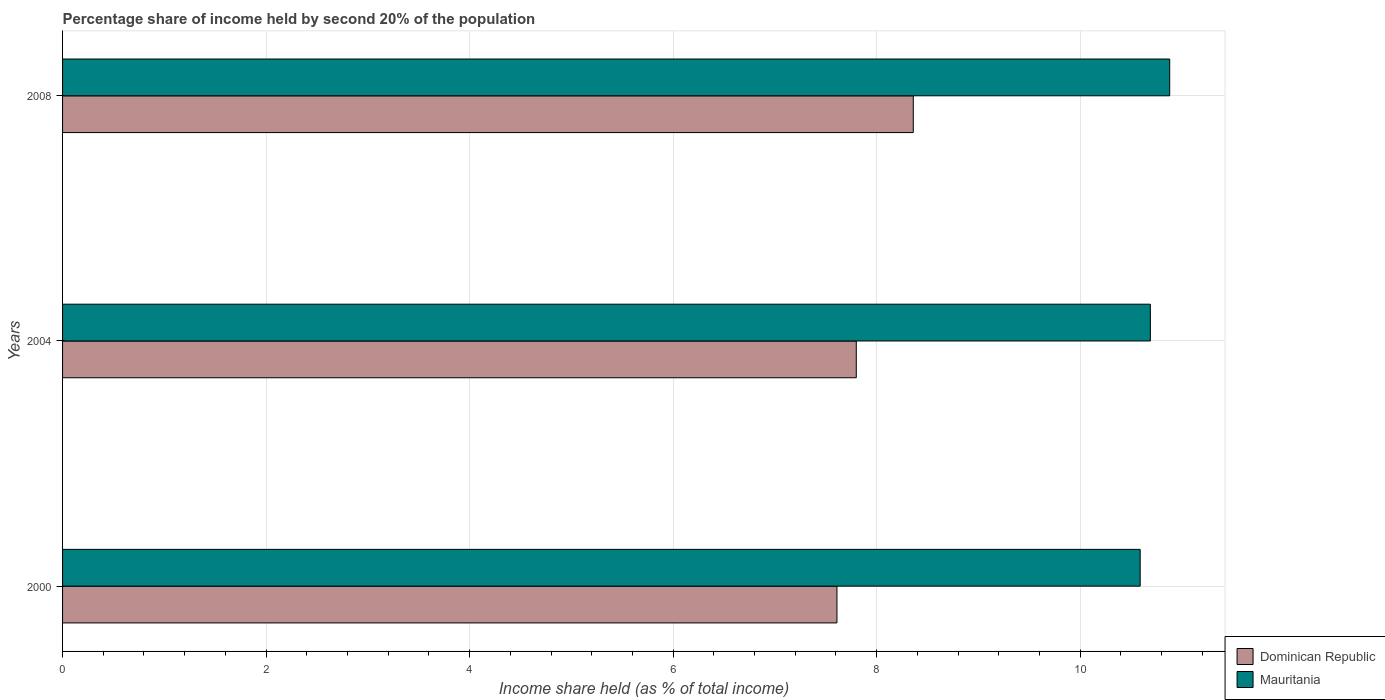Are the number of bars per tick equal to the number of legend labels?
Keep it short and to the point. Yes. What is the share of income held by second 20% of the population in Dominican Republic in 2008?
Give a very brief answer. 8.36. Across all years, what is the maximum share of income held by second 20% of the population in Dominican Republic?
Your response must be concise. 8.36. Across all years, what is the minimum share of income held by second 20% of the population in Mauritania?
Provide a short and direct response. 10.59. What is the total share of income held by second 20% of the population in Mauritania in the graph?
Provide a succinct answer. 32.16. What is the difference between the share of income held by second 20% of the population in Dominican Republic in 2004 and that in 2008?
Your response must be concise. -0.56. What is the difference between the share of income held by second 20% of the population in Dominican Republic in 2000 and the share of income held by second 20% of the population in Mauritania in 2008?
Provide a short and direct response. -3.27. What is the average share of income held by second 20% of the population in Dominican Republic per year?
Your answer should be very brief. 7.92. In the year 2008, what is the difference between the share of income held by second 20% of the population in Mauritania and share of income held by second 20% of the population in Dominican Republic?
Your answer should be compact. 2.52. What is the ratio of the share of income held by second 20% of the population in Dominican Republic in 2000 to that in 2008?
Provide a succinct answer. 0.91. What is the difference between the highest and the second highest share of income held by second 20% of the population in Mauritania?
Your response must be concise. 0.19. What is the difference between the highest and the lowest share of income held by second 20% of the population in Dominican Republic?
Offer a terse response. 0.75. What does the 2nd bar from the top in 2004 represents?
Offer a terse response. Dominican Republic. What does the 2nd bar from the bottom in 2000 represents?
Provide a succinct answer. Mauritania. How many bars are there?
Your answer should be compact. 6. Are all the bars in the graph horizontal?
Provide a succinct answer. Yes. How many years are there in the graph?
Ensure brevity in your answer.  3. What is the title of the graph?
Provide a short and direct response. Percentage share of income held by second 20% of the population. Does "East Asia (developing only)" appear as one of the legend labels in the graph?
Ensure brevity in your answer.  No. What is the label or title of the X-axis?
Make the answer very short. Income share held (as % of total income). What is the label or title of the Y-axis?
Give a very brief answer. Years. What is the Income share held (as % of total income) of Dominican Republic in 2000?
Offer a terse response. 7.61. What is the Income share held (as % of total income) in Mauritania in 2000?
Your answer should be very brief. 10.59. What is the Income share held (as % of total income) of Mauritania in 2004?
Make the answer very short. 10.69. What is the Income share held (as % of total income) of Dominican Republic in 2008?
Give a very brief answer. 8.36. What is the Income share held (as % of total income) in Mauritania in 2008?
Your response must be concise. 10.88. Across all years, what is the maximum Income share held (as % of total income) of Dominican Republic?
Your answer should be compact. 8.36. Across all years, what is the maximum Income share held (as % of total income) of Mauritania?
Provide a short and direct response. 10.88. Across all years, what is the minimum Income share held (as % of total income) in Dominican Republic?
Your answer should be compact. 7.61. Across all years, what is the minimum Income share held (as % of total income) of Mauritania?
Make the answer very short. 10.59. What is the total Income share held (as % of total income) in Dominican Republic in the graph?
Your answer should be compact. 23.77. What is the total Income share held (as % of total income) in Mauritania in the graph?
Provide a succinct answer. 32.16. What is the difference between the Income share held (as % of total income) of Dominican Republic in 2000 and that in 2004?
Your response must be concise. -0.19. What is the difference between the Income share held (as % of total income) in Dominican Republic in 2000 and that in 2008?
Offer a very short reply. -0.75. What is the difference between the Income share held (as % of total income) of Mauritania in 2000 and that in 2008?
Provide a short and direct response. -0.29. What is the difference between the Income share held (as % of total income) of Dominican Republic in 2004 and that in 2008?
Offer a very short reply. -0.56. What is the difference between the Income share held (as % of total income) of Mauritania in 2004 and that in 2008?
Make the answer very short. -0.19. What is the difference between the Income share held (as % of total income) of Dominican Republic in 2000 and the Income share held (as % of total income) of Mauritania in 2004?
Your response must be concise. -3.08. What is the difference between the Income share held (as % of total income) in Dominican Republic in 2000 and the Income share held (as % of total income) in Mauritania in 2008?
Make the answer very short. -3.27. What is the difference between the Income share held (as % of total income) of Dominican Republic in 2004 and the Income share held (as % of total income) of Mauritania in 2008?
Provide a succinct answer. -3.08. What is the average Income share held (as % of total income) of Dominican Republic per year?
Your response must be concise. 7.92. What is the average Income share held (as % of total income) of Mauritania per year?
Ensure brevity in your answer.  10.72. In the year 2000, what is the difference between the Income share held (as % of total income) in Dominican Republic and Income share held (as % of total income) in Mauritania?
Offer a very short reply. -2.98. In the year 2004, what is the difference between the Income share held (as % of total income) in Dominican Republic and Income share held (as % of total income) in Mauritania?
Offer a terse response. -2.89. In the year 2008, what is the difference between the Income share held (as % of total income) of Dominican Republic and Income share held (as % of total income) of Mauritania?
Provide a short and direct response. -2.52. What is the ratio of the Income share held (as % of total income) in Dominican Republic in 2000 to that in 2004?
Offer a very short reply. 0.98. What is the ratio of the Income share held (as % of total income) in Mauritania in 2000 to that in 2004?
Keep it short and to the point. 0.99. What is the ratio of the Income share held (as % of total income) of Dominican Republic in 2000 to that in 2008?
Ensure brevity in your answer.  0.91. What is the ratio of the Income share held (as % of total income) of Mauritania in 2000 to that in 2008?
Ensure brevity in your answer.  0.97. What is the ratio of the Income share held (as % of total income) in Dominican Republic in 2004 to that in 2008?
Keep it short and to the point. 0.93. What is the ratio of the Income share held (as % of total income) in Mauritania in 2004 to that in 2008?
Your answer should be compact. 0.98. What is the difference between the highest and the second highest Income share held (as % of total income) in Dominican Republic?
Your answer should be very brief. 0.56. What is the difference between the highest and the second highest Income share held (as % of total income) of Mauritania?
Your response must be concise. 0.19. What is the difference between the highest and the lowest Income share held (as % of total income) of Mauritania?
Provide a succinct answer. 0.29. 